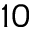<formula> <loc_0><loc_0><loc_500><loc_500>1 0</formula> 